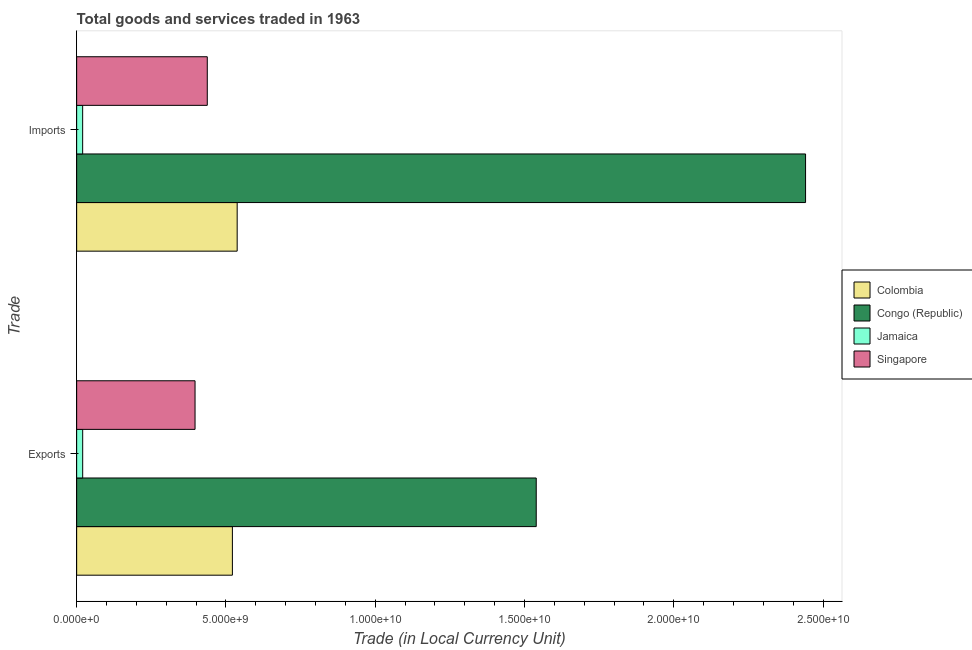How many different coloured bars are there?
Your answer should be very brief. 4. Are the number of bars per tick equal to the number of legend labels?
Give a very brief answer. Yes. How many bars are there on the 2nd tick from the top?
Your response must be concise. 4. What is the label of the 2nd group of bars from the top?
Your answer should be very brief. Exports. What is the export of goods and services in Colombia?
Your answer should be very brief. 5.22e+09. Across all countries, what is the maximum imports of goods and services?
Offer a terse response. 2.44e+1. Across all countries, what is the minimum imports of goods and services?
Give a very brief answer. 2.01e+08. In which country was the imports of goods and services maximum?
Make the answer very short. Congo (Republic). In which country was the export of goods and services minimum?
Give a very brief answer. Jamaica. What is the total export of goods and services in the graph?
Offer a very short reply. 2.48e+1. What is the difference between the export of goods and services in Singapore and that in Jamaica?
Give a very brief answer. 3.76e+09. What is the difference between the export of goods and services in Congo (Republic) and the imports of goods and services in Colombia?
Offer a terse response. 1.00e+1. What is the average export of goods and services per country?
Your answer should be compact. 6.19e+09. What is the difference between the export of goods and services and imports of goods and services in Colombia?
Provide a succinct answer. -1.60e+08. In how many countries, is the export of goods and services greater than 3000000000 LCU?
Your answer should be very brief. 3. What is the ratio of the export of goods and services in Colombia to that in Congo (Republic)?
Your answer should be very brief. 0.34. What does the 4th bar from the top in Exports represents?
Ensure brevity in your answer.  Colombia. What does the 3rd bar from the bottom in Exports represents?
Offer a terse response. Jamaica. Are all the bars in the graph horizontal?
Your response must be concise. Yes. How many countries are there in the graph?
Offer a terse response. 4. What is the difference between two consecutive major ticks on the X-axis?
Provide a short and direct response. 5.00e+09. Are the values on the major ticks of X-axis written in scientific E-notation?
Keep it short and to the point. Yes. Does the graph contain grids?
Keep it short and to the point. No. How many legend labels are there?
Make the answer very short. 4. What is the title of the graph?
Make the answer very short. Total goods and services traded in 1963. What is the label or title of the X-axis?
Your answer should be compact. Trade (in Local Currency Unit). What is the label or title of the Y-axis?
Provide a succinct answer. Trade. What is the Trade (in Local Currency Unit) of Colombia in Exports?
Provide a succinct answer. 5.22e+09. What is the Trade (in Local Currency Unit) in Congo (Republic) in Exports?
Ensure brevity in your answer.  1.54e+1. What is the Trade (in Local Currency Unit) of Jamaica in Exports?
Keep it short and to the point. 2.02e+08. What is the Trade (in Local Currency Unit) in Singapore in Exports?
Offer a very short reply. 3.96e+09. What is the Trade (in Local Currency Unit) of Colombia in Imports?
Ensure brevity in your answer.  5.38e+09. What is the Trade (in Local Currency Unit) of Congo (Republic) in Imports?
Your answer should be very brief. 2.44e+1. What is the Trade (in Local Currency Unit) in Jamaica in Imports?
Provide a short and direct response. 2.01e+08. What is the Trade (in Local Currency Unit) in Singapore in Imports?
Your response must be concise. 4.37e+09. Across all Trade, what is the maximum Trade (in Local Currency Unit) in Colombia?
Your answer should be compact. 5.38e+09. Across all Trade, what is the maximum Trade (in Local Currency Unit) of Congo (Republic)?
Give a very brief answer. 2.44e+1. Across all Trade, what is the maximum Trade (in Local Currency Unit) in Jamaica?
Your answer should be compact. 2.02e+08. Across all Trade, what is the maximum Trade (in Local Currency Unit) in Singapore?
Offer a terse response. 4.37e+09. Across all Trade, what is the minimum Trade (in Local Currency Unit) in Colombia?
Offer a very short reply. 5.22e+09. Across all Trade, what is the minimum Trade (in Local Currency Unit) in Congo (Republic)?
Provide a short and direct response. 1.54e+1. Across all Trade, what is the minimum Trade (in Local Currency Unit) of Jamaica?
Offer a terse response. 2.01e+08. Across all Trade, what is the minimum Trade (in Local Currency Unit) in Singapore?
Your answer should be compact. 3.96e+09. What is the total Trade (in Local Currency Unit) in Colombia in the graph?
Offer a terse response. 1.06e+1. What is the total Trade (in Local Currency Unit) in Congo (Republic) in the graph?
Keep it short and to the point. 3.98e+1. What is the total Trade (in Local Currency Unit) of Jamaica in the graph?
Your answer should be very brief. 4.03e+08. What is the total Trade (in Local Currency Unit) in Singapore in the graph?
Ensure brevity in your answer.  8.34e+09. What is the difference between the Trade (in Local Currency Unit) in Colombia in Exports and that in Imports?
Give a very brief answer. -1.60e+08. What is the difference between the Trade (in Local Currency Unit) of Congo (Republic) in Exports and that in Imports?
Your answer should be compact. -9.02e+09. What is the difference between the Trade (in Local Currency Unit) of Jamaica in Exports and that in Imports?
Ensure brevity in your answer.  7.54e+05. What is the difference between the Trade (in Local Currency Unit) of Singapore in Exports and that in Imports?
Give a very brief answer. -4.09e+08. What is the difference between the Trade (in Local Currency Unit) in Colombia in Exports and the Trade (in Local Currency Unit) in Congo (Republic) in Imports?
Your answer should be compact. -1.92e+1. What is the difference between the Trade (in Local Currency Unit) of Colombia in Exports and the Trade (in Local Currency Unit) of Jamaica in Imports?
Keep it short and to the point. 5.01e+09. What is the difference between the Trade (in Local Currency Unit) in Colombia in Exports and the Trade (in Local Currency Unit) in Singapore in Imports?
Make the answer very short. 8.41e+08. What is the difference between the Trade (in Local Currency Unit) of Congo (Republic) in Exports and the Trade (in Local Currency Unit) of Jamaica in Imports?
Keep it short and to the point. 1.52e+1. What is the difference between the Trade (in Local Currency Unit) of Congo (Republic) in Exports and the Trade (in Local Currency Unit) of Singapore in Imports?
Your answer should be very brief. 1.10e+1. What is the difference between the Trade (in Local Currency Unit) in Jamaica in Exports and the Trade (in Local Currency Unit) in Singapore in Imports?
Make the answer very short. -4.17e+09. What is the average Trade (in Local Currency Unit) in Colombia per Trade?
Your response must be concise. 5.30e+09. What is the average Trade (in Local Currency Unit) of Congo (Republic) per Trade?
Provide a succinct answer. 1.99e+1. What is the average Trade (in Local Currency Unit) in Jamaica per Trade?
Your answer should be compact. 2.01e+08. What is the average Trade (in Local Currency Unit) in Singapore per Trade?
Offer a terse response. 4.17e+09. What is the difference between the Trade (in Local Currency Unit) in Colombia and Trade (in Local Currency Unit) in Congo (Republic) in Exports?
Keep it short and to the point. -1.02e+1. What is the difference between the Trade (in Local Currency Unit) in Colombia and Trade (in Local Currency Unit) in Jamaica in Exports?
Provide a succinct answer. 5.01e+09. What is the difference between the Trade (in Local Currency Unit) in Colombia and Trade (in Local Currency Unit) in Singapore in Exports?
Offer a very short reply. 1.25e+09. What is the difference between the Trade (in Local Currency Unit) in Congo (Republic) and Trade (in Local Currency Unit) in Jamaica in Exports?
Give a very brief answer. 1.52e+1. What is the difference between the Trade (in Local Currency Unit) of Congo (Republic) and Trade (in Local Currency Unit) of Singapore in Exports?
Provide a short and direct response. 1.14e+1. What is the difference between the Trade (in Local Currency Unit) of Jamaica and Trade (in Local Currency Unit) of Singapore in Exports?
Offer a very short reply. -3.76e+09. What is the difference between the Trade (in Local Currency Unit) of Colombia and Trade (in Local Currency Unit) of Congo (Republic) in Imports?
Provide a short and direct response. -1.90e+1. What is the difference between the Trade (in Local Currency Unit) of Colombia and Trade (in Local Currency Unit) of Jamaica in Imports?
Give a very brief answer. 5.17e+09. What is the difference between the Trade (in Local Currency Unit) of Colombia and Trade (in Local Currency Unit) of Singapore in Imports?
Keep it short and to the point. 1.00e+09. What is the difference between the Trade (in Local Currency Unit) of Congo (Republic) and Trade (in Local Currency Unit) of Jamaica in Imports?
Give a very brief answer. 2.42e+1. What is the difference between the Trade (in Local Currency Unit) in Congo (Republic) and Trade (in Local Currency Unit) in Singapore in Imports?
Give a very brief answer. 2.00e+1. What is the difference between the Trade (in Local Currency Unit) in Jamaica and Trade (in Local Currency Unit) in Singapore in Imports?
Ensure brevity in your answer.  -4.17e+09. What is the ratio of the Trade (in Local Currency Unit) in Colombia in Exports to that in Imports?
Provide a short and direct response. 0.97. What is the ratio of the Trade (in Local Currency Unit) of Congo (Republic) in Exports to that in Imports?
Provide a short and direct response. 0.63. What is the ratio of the Trade (in Local Currency Unit) in Jamaica in Exports to that in Imports?
Your answer should be very brief. 1. What is the ratio of the Trade (in Local Currency Unit) in Singapore in Exports to that in Imports?
Keep it short and to the point. 0.91. What is the difference between the highest and the second highest Trade (in Local Currency Unit) of Colombia?
Provide a succinct answer. 1.60e+08. What is the difference between the highest and the second highest Trade (in Local Currency Unit) in Congo (Republic)?
Provide a succinct answer. 9.02e+09. What is the difference between the highest and the second highest Trade (in Local Currency Unit) in Jamaica?
Offer a very short reply. 7.54e+05. What is the difference between the highest and the second highest Trade (in Local Currency Unit) of Singapore?
Keep it short and to the point. 4.09e+08. What is the difference between the highest and the lowest Trade (in Local Currency Unit) in Colombia?
Offer a terse response. 1.60e+08. What is the difference between the highest and the lowest Trade (in Local Currency Unit) of Congo (Republic)?
Ensure brevity in your answer.  9.02e+09. What is the difference between the highest and the lowest Trade (in Local Currency Unit) in Jamaica?
Make the answer very short. 7.54e+05. What is the difference between the highest and the lowest Trade (in Local Currency Unit) in Singapore?
Your answer should be very brief. 4.09e+08. 